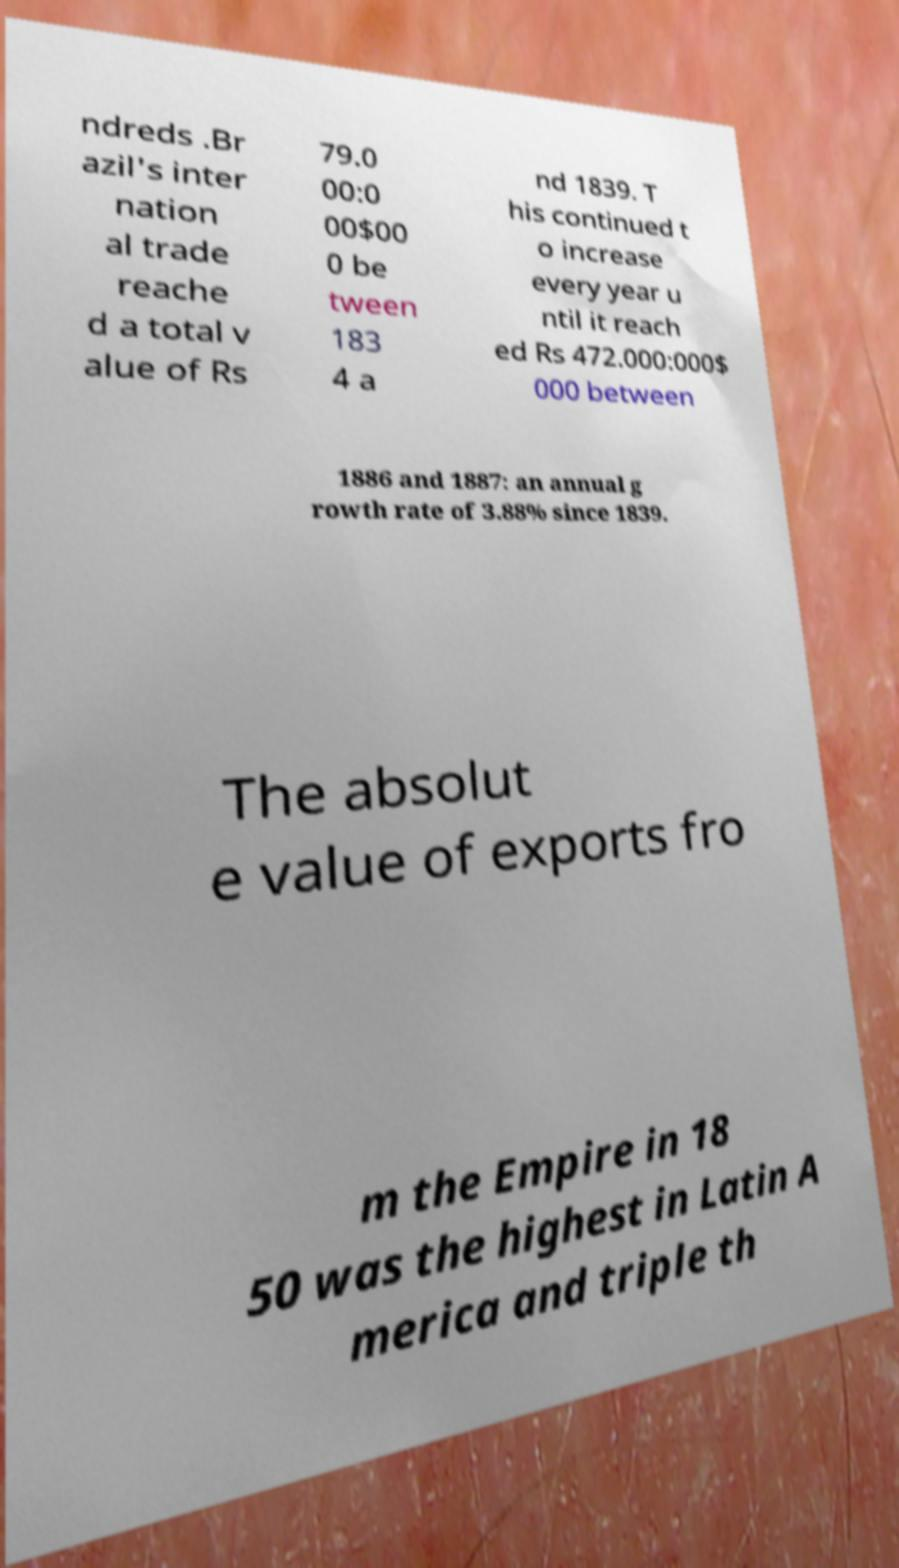Could you assist in decoding the text presented in this image and type it out clearly? ndreds .Br azil's inter nation al trade reache d a total v alue of Rs 79.0 00:0 00$00 0 be tween 183 4 a nd 1839. T his continued t o increase every year u ntil it reach ed Rs 472.000:000$ 000 between 1886 and 1887: an annual g rowth rate of 3.88% since 1839. The absolut e value of exports fro m the Empire in 18 50 was the highest in Latin A merica and triple th 